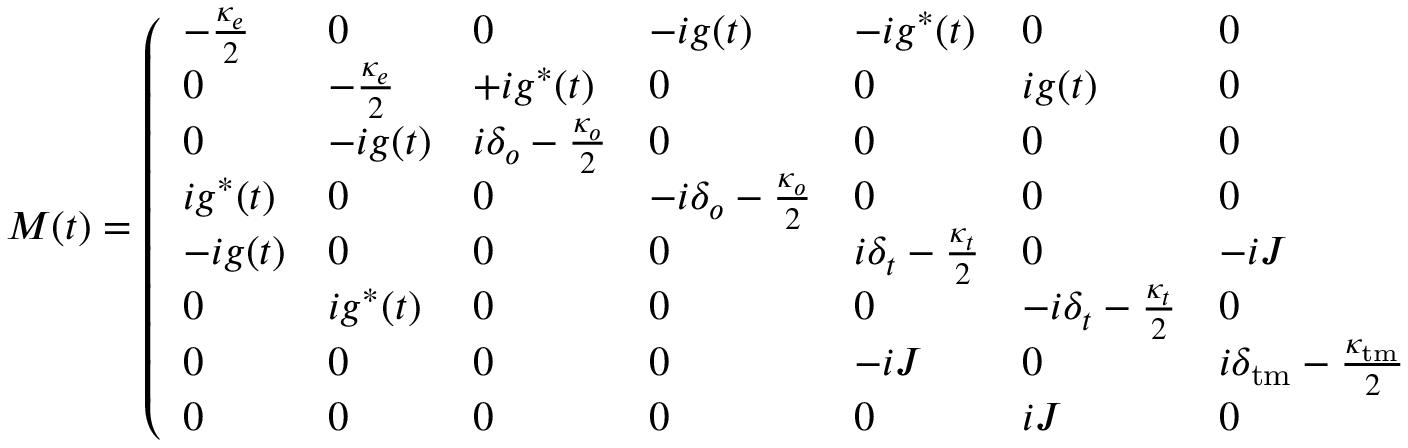Convert formula to latex. <formula><loc_0><loc_0><loc_500><loc_500>M ( t ) = \left ( \begin{array} { l l l l l l l l } { - \frac { \kappa _ { e } } { 2 } } & { 0 } & { 0 } & { - i g ( t ) } & { - i g ^ { * } ( t ) } & { 0 } & { 0 } & { 0 } \\ { 0 } & { - \frac { \kappa _ { e } } { 2 } } & { + i g ^ { * } ( t ) } & { 0 } & { 0 } & { i g ( t ) } & { 0 } & { 0 } \\ { 0 } & { - i g ( t ) } & { i \delta _ { o } - \frac { \kappa _ { o } } { 2 } } & { 0 } & { 0 } & { 0 } & { 0 } & { 0 } \\ { i g ^ { * } ( t ) } & { 0 } & { 0 } & { - i \delta _ { o } - \frac { \kappa _ { o } } { 2 } } & { 0 } & { 0 } & { 0 } & { 0 } \\ { - i g ( t ) } & { 0 } & { 0 } & { 0 } & { i \delta _ { t } - \frac { \kappa _ { t } } { 2 } } & { 0 } & { - i J } & { 0 } \\ { 0 } & { i g ^ { * } ( t ) } & { 0 } & { 0 } & { 0 } & { - i \delta _ { t } - \frac { \kappa _ { t } } { 2 } } & { 0 } & { i J } \\ { 0 } & { 0 } & { 0 } & { 0 } & { - i J } & { 0 } & { i \delta _ { t m } - \frac { \kappa _ { t m } } { 2 } } & { 0 } \\ { 0 } & { 0 } & { 0 } & { 0 } & { 0 } & { i J } & { 0 } & { - i \delta _ { t m } - \frac { \kappa _ { t m } } { 2 } } \end{array} \right ) ,</formula> 